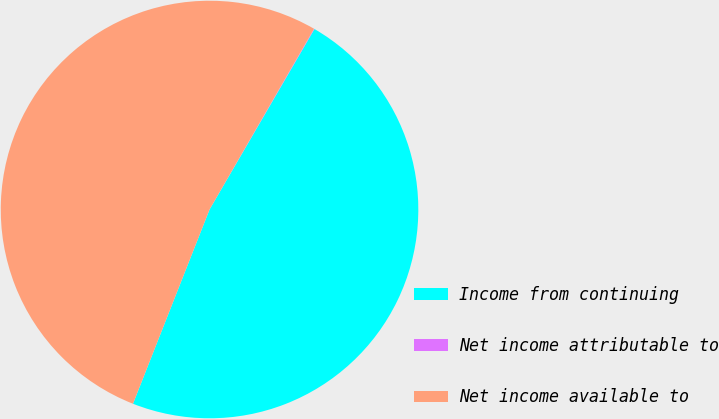Convert chart to OTSL. <chart><loc_0><loc_0><loc_500><loc_500><pie_chart><fcel>Income from continuing<fcel>Net income attributable to<fcel>Net income available to<nl><fcel>47.59%<fcel>0.04%<fcel>52.36%<nl></chart> 